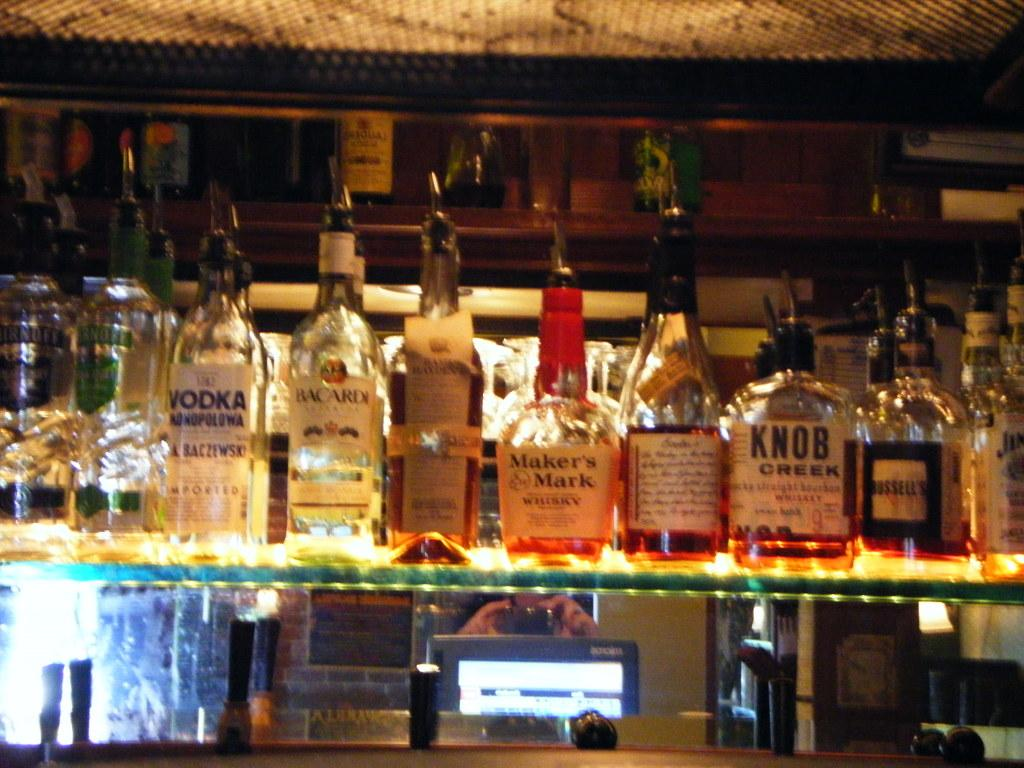<image>
Share a concise interpretation of the image provided. Multiple bottles of liquor lie on a shelf including Maker's Mark Whisky. 